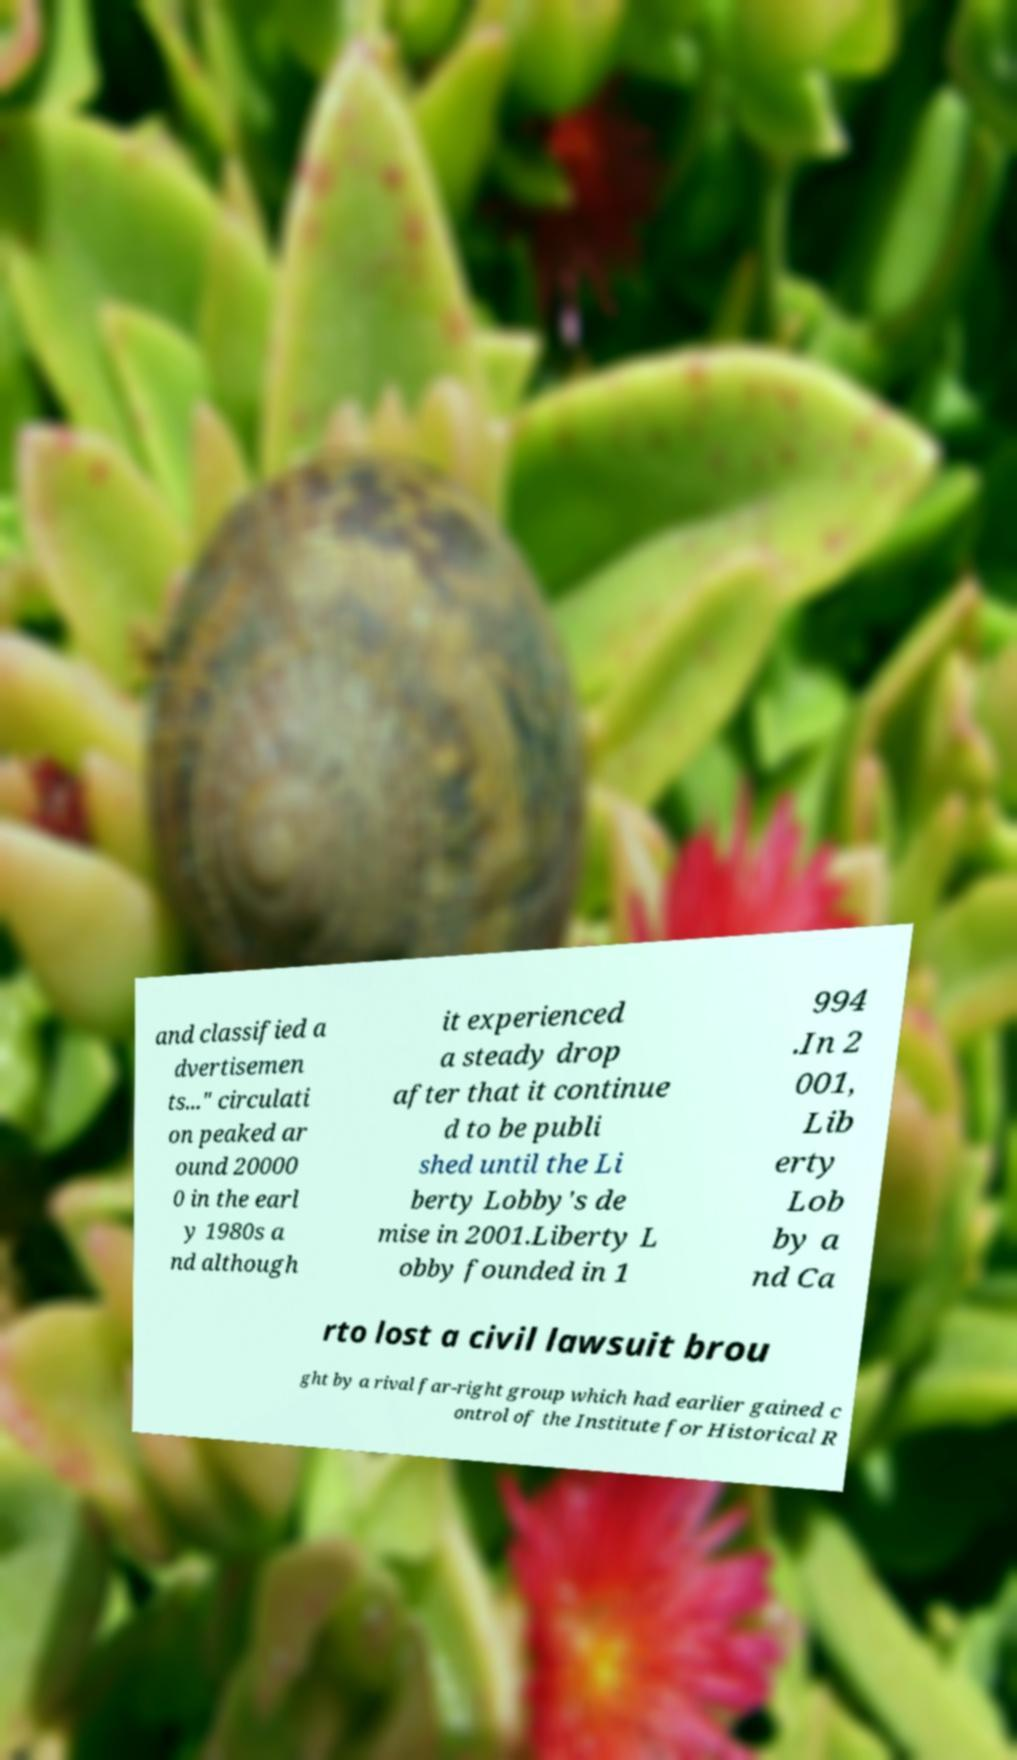Can you accurately transcribe the text from the provided image for me? and classified a dvertisemen ts..." circulati on peaked ar ound 20000 0 in the earl y 1980s a nd although it experienced a steady drop after that it continue d to be publi shed until the Li berty Lobby's de mise in 2001.Liberty L obby founded in 1 994 .In 2 001, Lib erty Lob by a nd Ca rto lost a civil lawsuit brou ght by a rival far-right group which had earlier gained c ontrol of the Institute for Historical R 